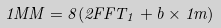<formula> <loc_0><loc_0><loc_500><loc_500>1 M M = 8 ( 2 F F T _ { 1 } + b \times 1 m )</formula> 